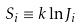Convert formula to latex. <formula><loc_0><loc_0><loc_500><loc_500>S _ { i } \equiv k \ln J _ { i }</formula> 